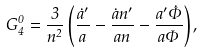<formula> <loc_0><loc_0><loc_500><loc_500>G ^ { 0 } _ { 4 } = \frac { 3 } { n ^ { 2 } } \left ( \frac { { \dot { a } } ^ { \prime } } { a } - \frac { \dot { a } n ^ { \prime } } { a n } - \frac { a ^ { \prime } \dot { \Phi } } { a \Phi } \right ) ,</formula> 